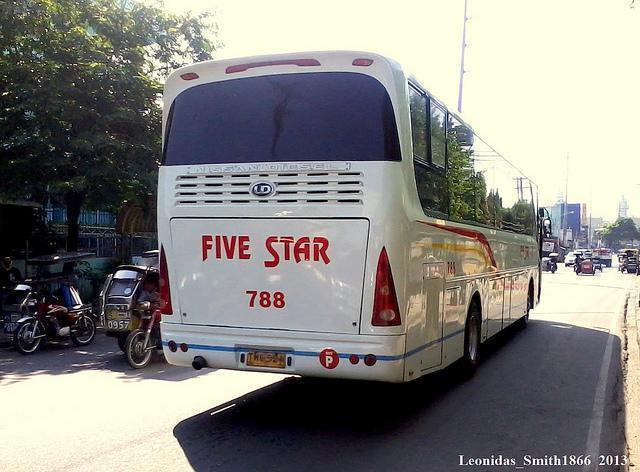What letter is on the bumper?
Indicate the correct response by choosing from the four available options to answer the question.
Options: P, , g, o. P. 